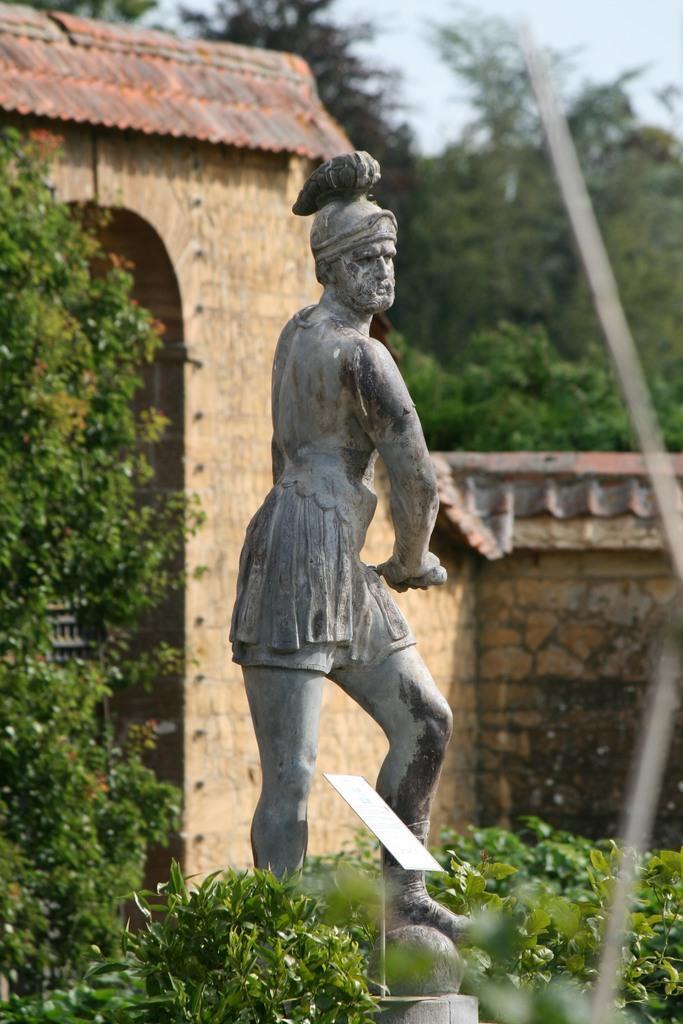Describe this image in one or two sentences. In this image I can see a statue of a person standing which is grey and black in color. I can see few trees which are green in color. In the background I can see the wall, an arch, few trees and the sky. 